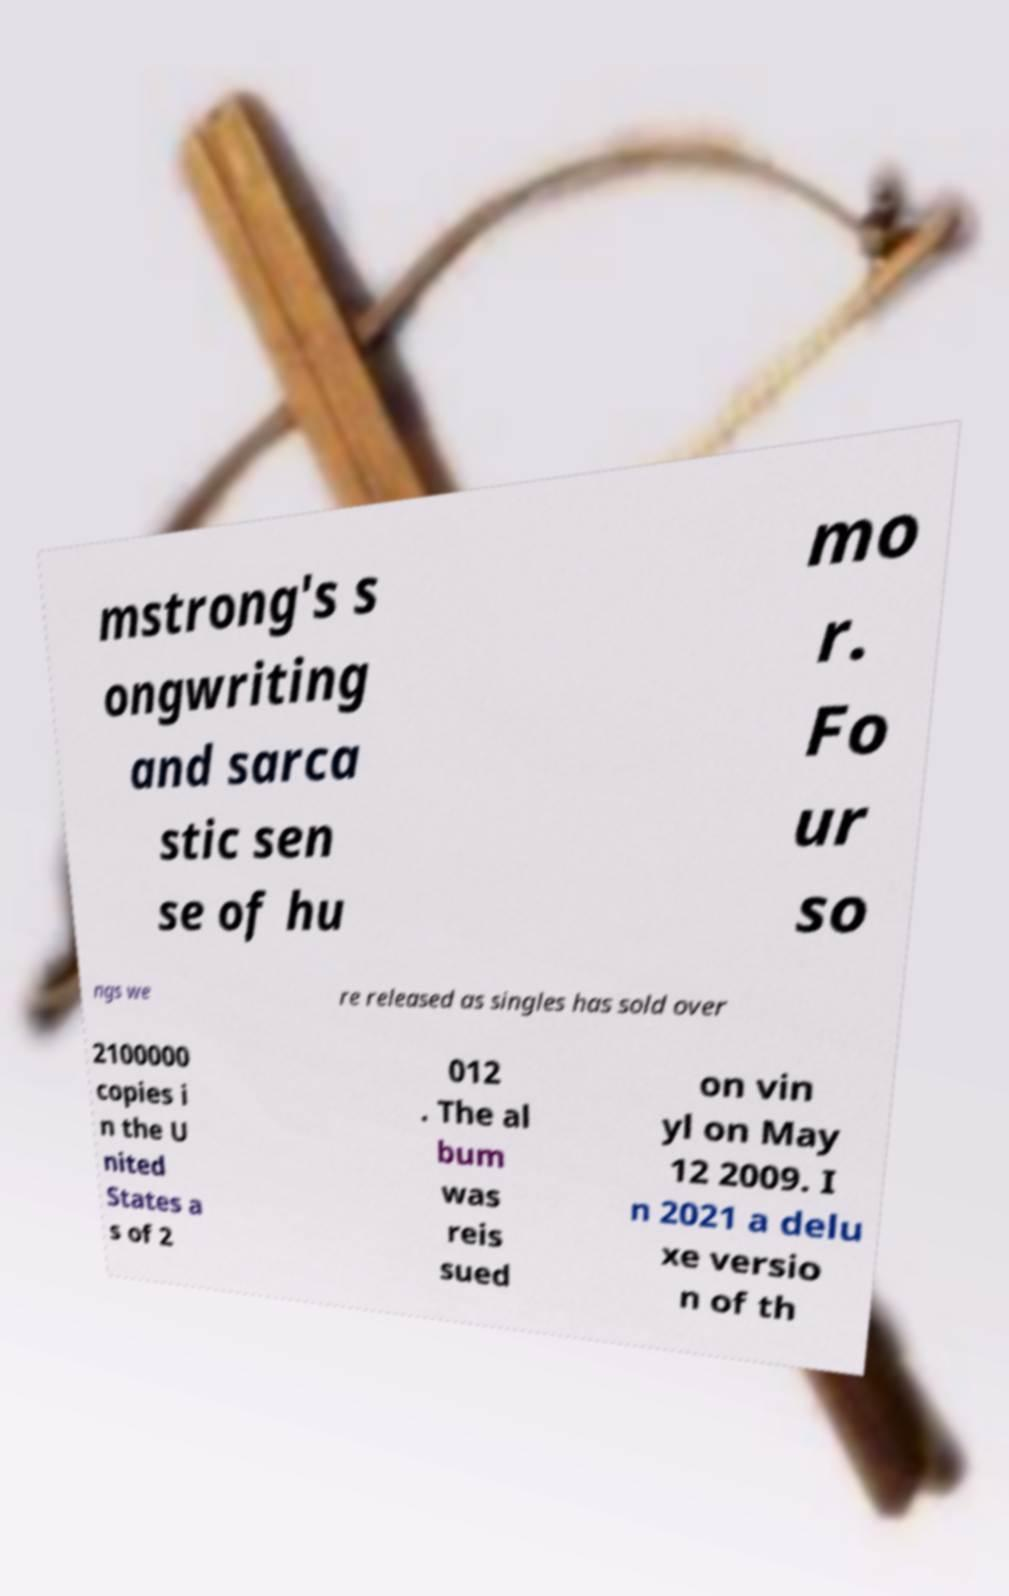Could you extract and type out the text from this image? mstrong's s ongwriting and sarca stic sen se of hu mo r. Fo ur so ngs we re released as singles has sold over 2100000 copies i n the U nited States a s of 2 012 . The al bum was reis sued on vin yl on May 12 2009. I n 2021 a delu xe versio n of th 